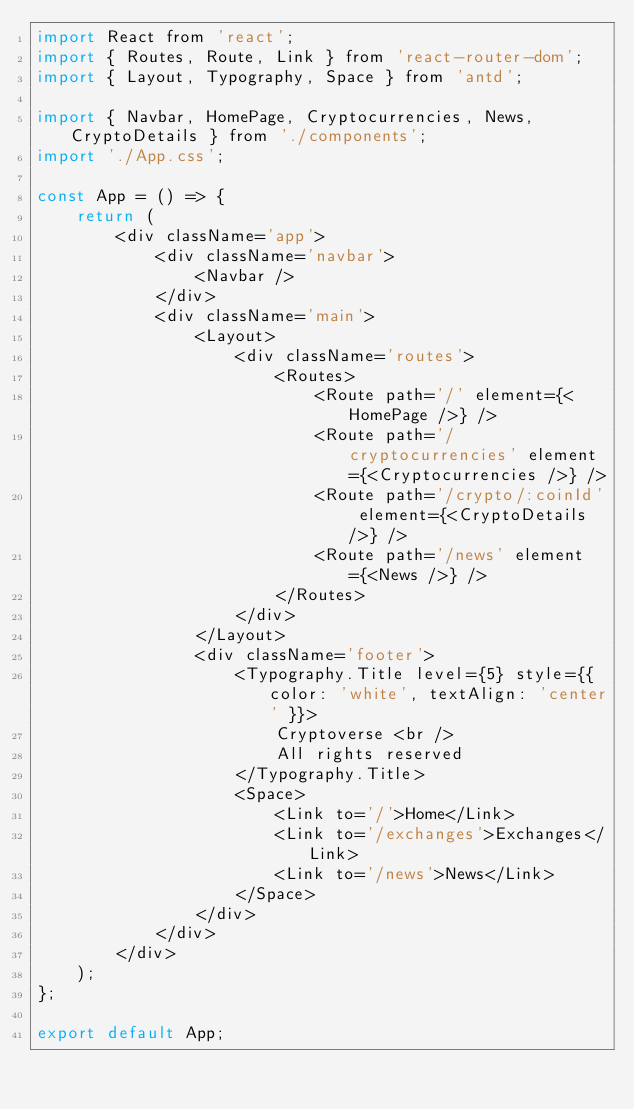<code> <loc_0><loc_0><loc_500><loc_500><_JavaScript_>import React from 'react';
import { Routes, Route, Link } from 'react-router-dom';
import { Layout, Typography, Space } from 'antd';

import { Navbar, HomePage, Cryptocurrencies, News, CryptoDetails } from './components';
import './App.css';

const App = () => {
    return (
        <div className='app'>
            <div className='navbar'>
                <Navbar />
            </div>
            <div className='main'>
                <Layout>
                    <div className='routes'>
                        <Routes>
                            <Route path='/' element={<HomePage />} />
                            <Route path='/cryptocurrencies' element={<Cryptocurrencies />} />
                            <Route path='/crypto/:coinId' element={<CryptoDetails />} />
                            <Route path='/news' element={<News />} />
                        </Routes>
                    </div>
                </Layout>
                <div className='footer'>
                    <Typography.Title level={5} style={{ color: 'white', textAlign: 'center' }}>
                        Cryptoverse <br />
                        All rights reserved
                    </Typography.Title>
                    <Space>
                        <Link to='/'>Home</Link>
                        <Link to='/exchanges'>Exchanges</Link>
                        <Link to='/news'>News</Link>
                    </Space>
                </div>
            </div>
        </div>
    );
};

export default App;</code> 